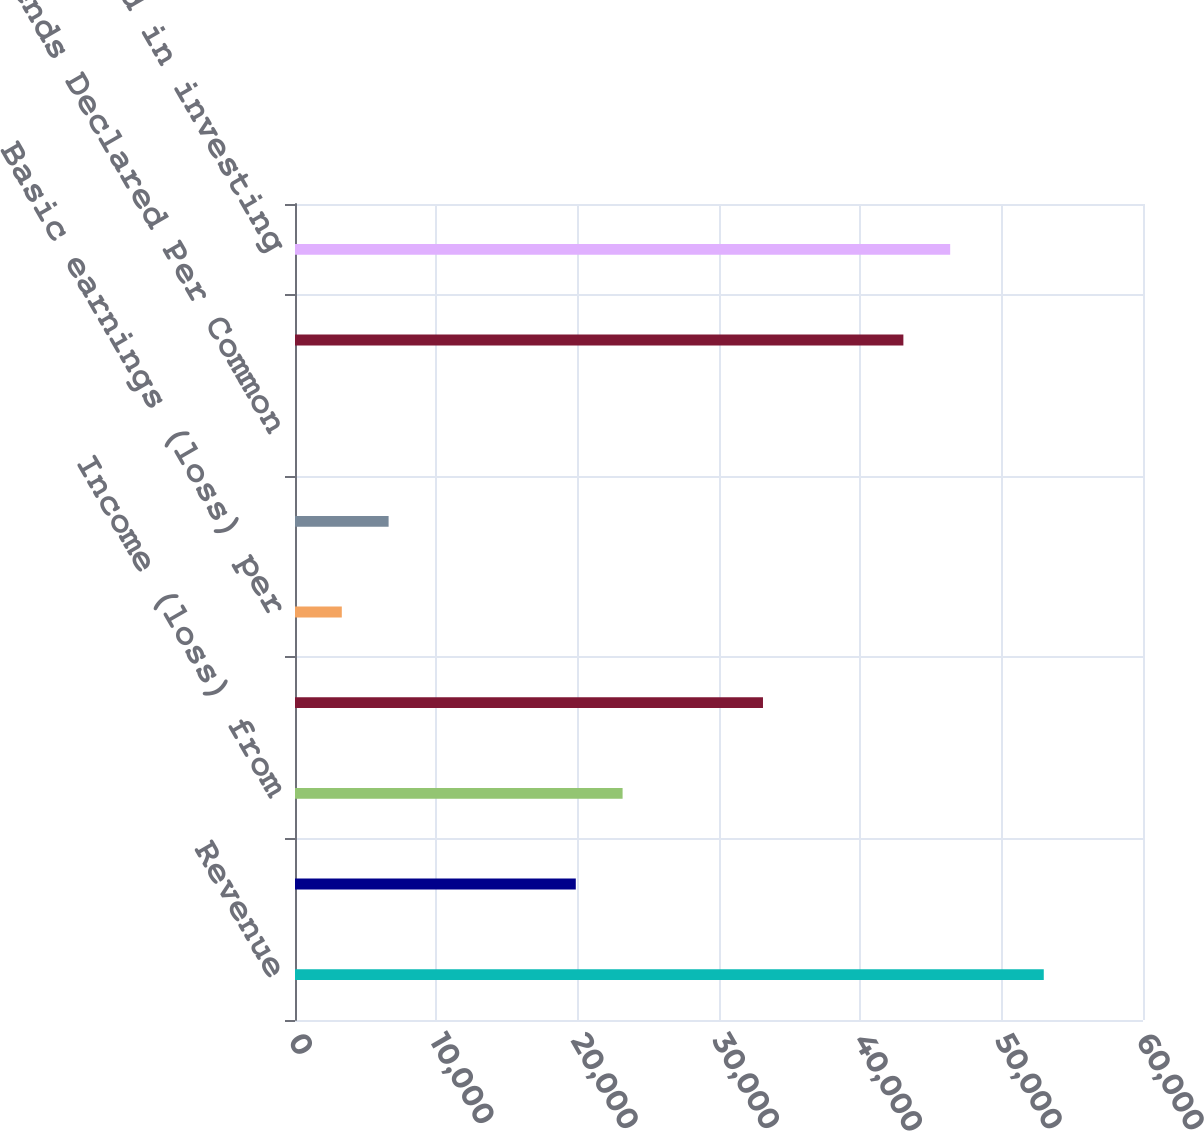Convert chart. <chart><loc_0><loc_0><loc_500><loc_500><bar_chart><fcel>Revenue<fcel>Income (loss) from continuing<fcel>Income (loss) from<fcel>Net income (loss) attributable<fcel>Basic earnings (loss) per<fcel>Diluted earnings (loss) per<fcel>Dividends Declared Per Common<fcel>Net cash provided by operating<fcel>Net cash used in investing<nl><fcel>52978.9<fcel>19867.4<fcel>23178.5<fcel>33112<fcel>3311.64<fcel>6622.79<fcel>0.49<fcel>43045.4<fcel>46356.6<nl></chart> 